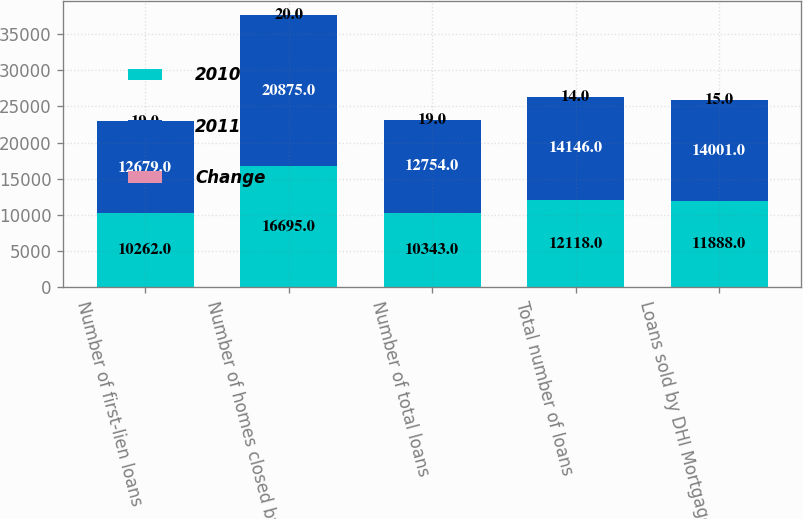Convert chart to OTSL. <chart><loc_0><loc_0><loc_500><loc_500><stacked_bar_chart><ecel><fcel>Number of first-lien loans<fcel>Number of homes closed by DR<fcel>Number of total loans<fcel>Total number of loans<fcel>Loans sold by DHI Mortgage to<nl><fcel>2010<fcel>10262<fcel>16695<fcel>10343<fcel>12118<fcel>11888<nl><fcel>2011<fcel>12679<fcel>20875<fcel>12754<fcel>14146<fcel>14001<nl><fcel>Change<fcel>19<fcel>20<fcel>19<fcel>14<fcel>15<nl></chart> 